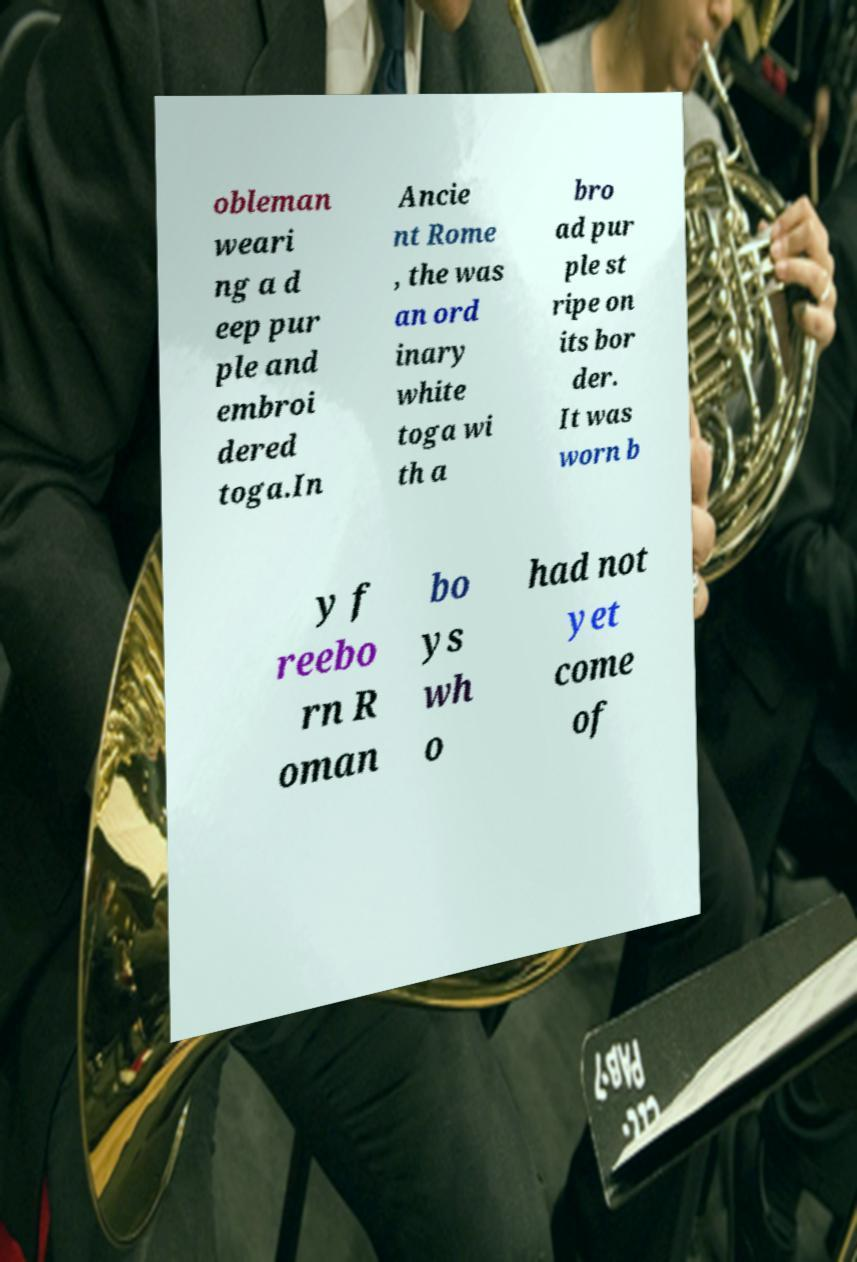For documentation purposes, I need the text within this image transcribed. Could you provide that? obleman weari ng a d eep pur ple and embroi dered toga.In Ancie nt Rome , the was an ord inary white toga wi th a bro ad pur ple st ripe on its bor der. It was worn b y f reebo rn R oman bo ys wh o had not yet come of 